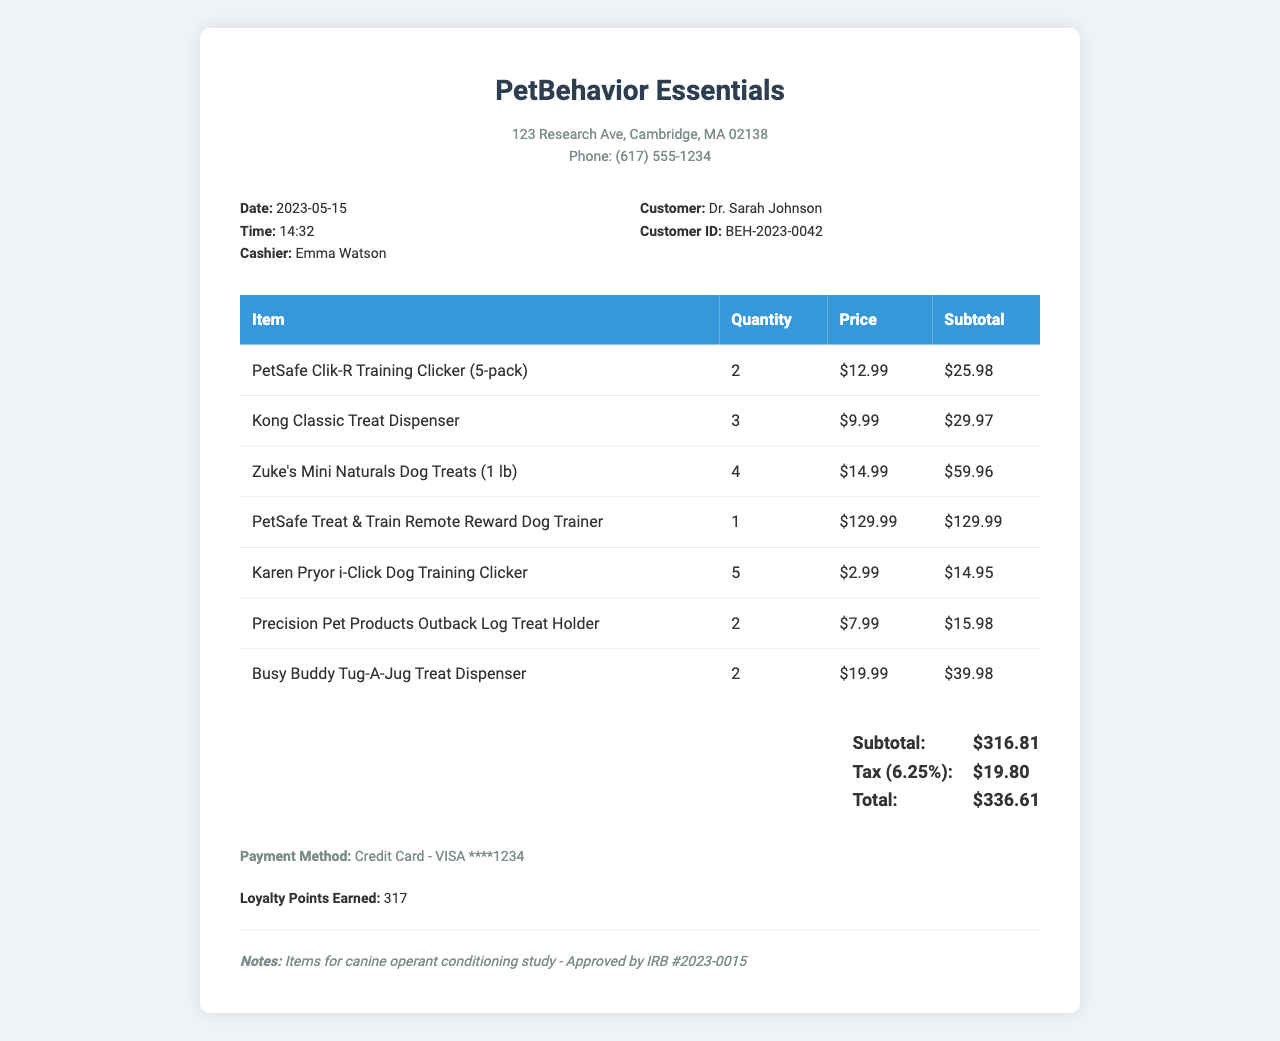What is the store name? The store name is printed prominently at the top of the receipt.
Answer: PetBehavior Essentials What date was the receipt issued? The date of the transaction is specified in the receipt details.
Answer: 2023-05-15 What is the total amount paid? The total amount paid is indicated in the total section of the receipt.
Answer: $336.61 Who is the cashier? The name of the cashier is listed in the receipt details.
Answer: Emma Watson How many items of the PetSafe Clik-R Training Clicker were purchased? The quantity purchased for each item is listed in the items table.
Answer: 2 What is the subtotal before tax? The subtotal is calculated before adding tax and is found in the total section.
Answer: $316.81 What is indicated in the notes section? The notes section includes important information regarding the purchase.
Answer: Items for canine operant conditioning study - Approved by IRB #2023-0015 How many loyalty points were earned? The loyalty points earned are explicitly stated in the customer information section.
Answer: 317 What type of payment method was used? The payment method is specified in the payment information section.
Answer: Credit Card - VISA ****1234 